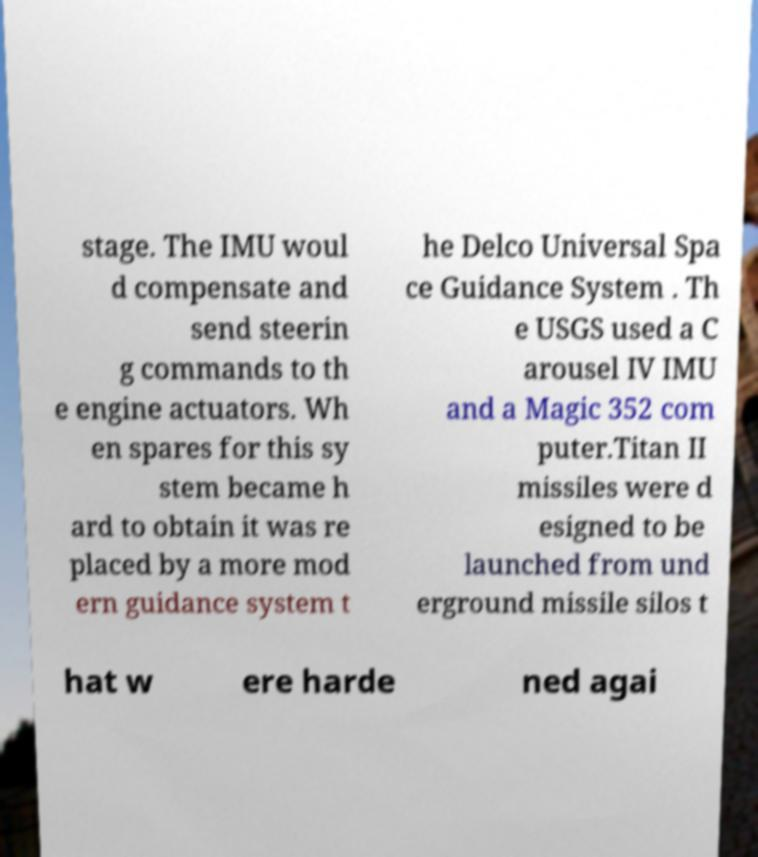Could you assist in decoding the text presented in this image and type it out clearly? stage. The IMU woul d compensate and send steerin g commands to th e engine actuators. Wh en spares for this sy stem became h ard to obtain it was re placed by a more mod ern guidance system t he Delco Universal Spa ce Guidance System . Th e USGS used a C arousel IV IMU and a Magic 352 com puter.Titan II missiles were d esigned to be launched from und erground missile silos t hat w ere harde ned agai 